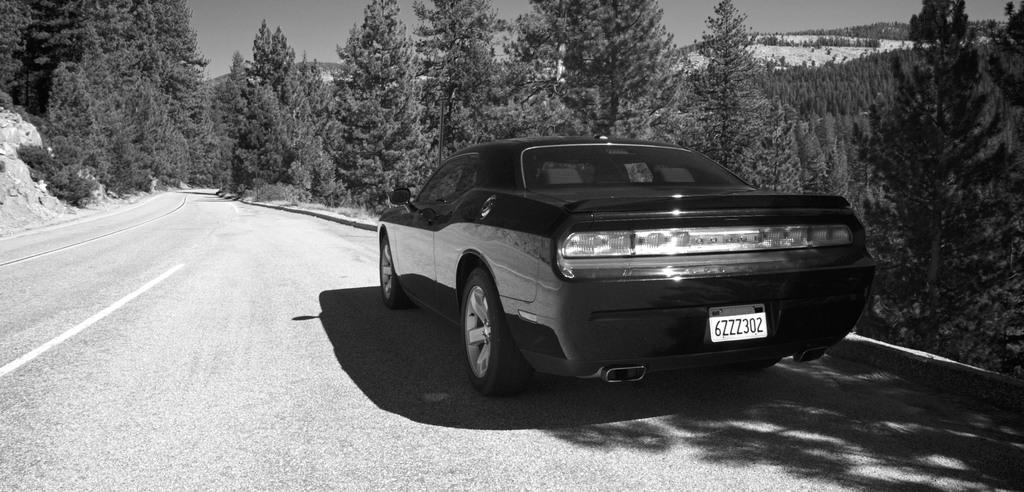What is the color scheme of the image? The image is black and white. What can be seen in the image? There is a car in the image. What is the car doing in the image? The car is moving on a road. What can be seen in the background of the image? There are trees, hills, and the sky visible in the background of the image. What type of behavior does the loss exhibit in the image? There is no loss present in the image; it features a car moving on a road with a black and white color scheme. 